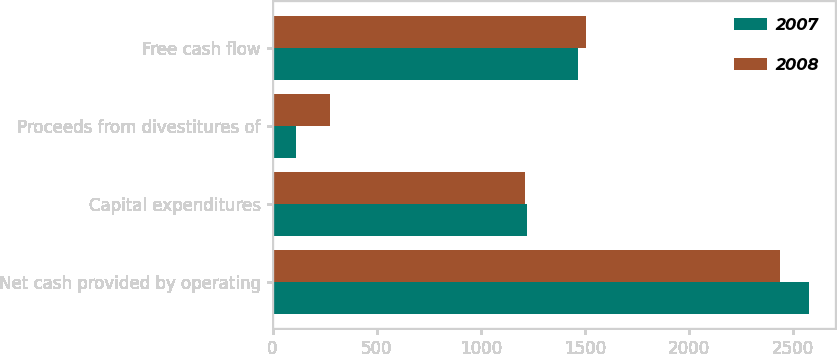<chart> <loc_0><loc_0><loc_500><loc_500><stacked_bar_chart><ecel><fcel>Net cash provided by operating<fcel>Capital expenditures<fcel>Proceeds from divestitures of<fcel>Free cash flow<nl><fcel>2007<fcel>2575<fcel>1221<fcel>112<fcel>1466<nl><fcel>2008<fcel>2439<fcel>1211<fcel>278<fcel>1506<nl></chart> 